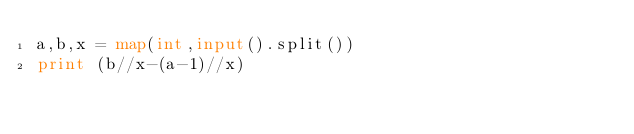Convert code to text. <code><loc_0><loc_0><loc_500><loc_500><_Python_>a,b,x = map(int,input().split())
print (b//x-(a-1)//x)</code> 